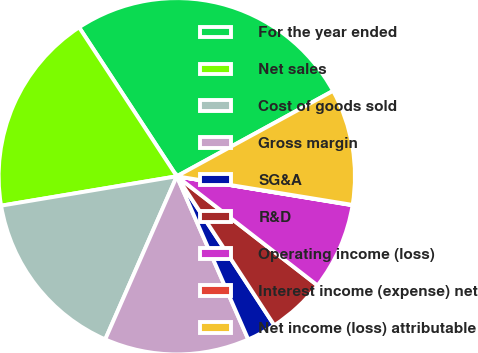Convert chart to OTSL. <chart><loc_0><loc_0><loc_500><loc_500><pie_chart><fcel>For the year ended<fcel>Net sales<fcel>Cost of goods sold<fcel>Gross margin<fcel>SG&A<fcel>R&D<fcel>Operating income (loss)<fcel>Interest income (expense) net<fcel>Net income (loss) attributable<nl><fcel>26.28%<fcel>18.4%<fcel>15.78%<fcel>13.15%<fcel>2.65%<fcel>5.28%<fcel>7.9%<fcel>0.03%<fcel>10.53%<nl></chart> 